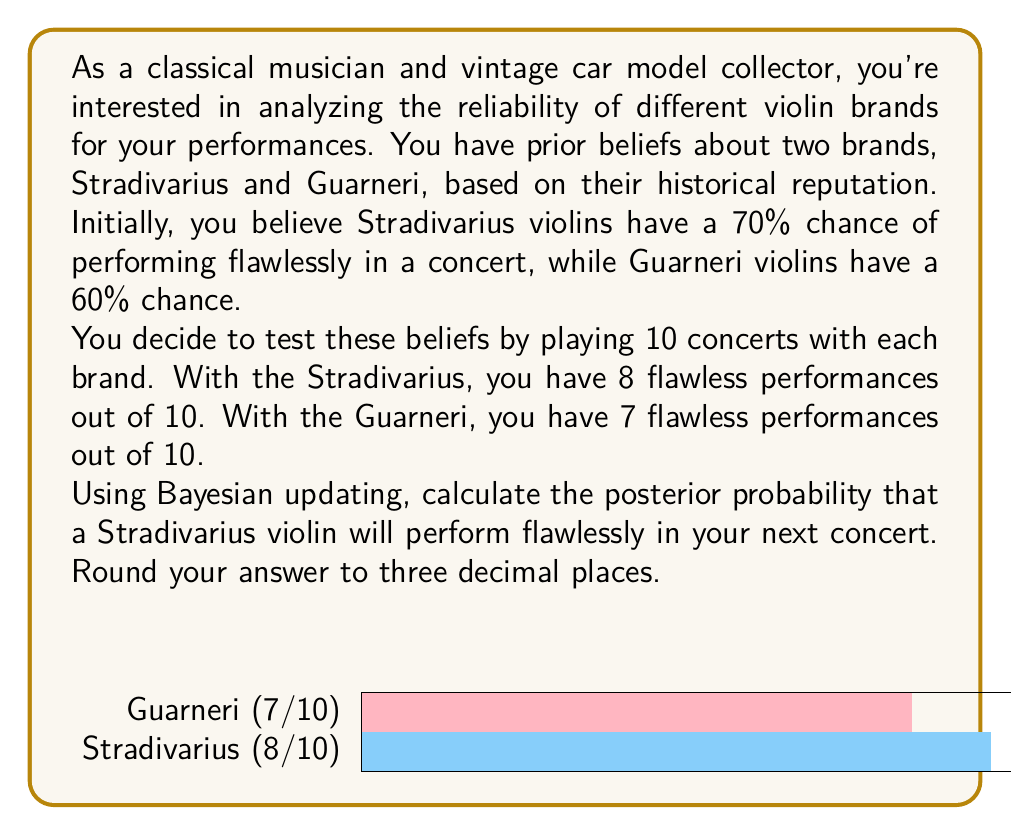Can you answer this question? Let's approach this step-by-step using Bayes' theorem:

1) Let $H$ be the event that a Stradivarius violin performs flawlessly.

2) Our prior probability: $P(H) = 0.70$

3) We observed 8 flawless performances out of 10 trials. This is our likelihood:
   $P(D|H) = \binom{10}{8} * 0.70^8 * 0.30^2 = 0.2334$

4) To calculate $P(D)$, we need to consider both possibilities (flawless and not flawless):
   $P(D) = P(D|H)P(H) + P(D|\neg H)P(\neg H)$
   $= (0.2334 * 0.70) + (\binom{10}{8} * 0.30^8 * 0.70^2 * 0.30)$
   $= 0.1634 + 0.0001 = 0.1635$

5) Now we can apply Bayes' theorem:

   $$P(H|D) = \frac{P(D|H)P(H)}{P(D)}$$

   $$P(H|D) = \frac{0.2334 * 0.70}{0.1635} = 0.9993$$

6) Rounding to three decimal places: 0.999

This means that after observing the new data, we are 99.9% confident that a Stradivarius violin will perform flawlessly in the next concert.
Answer: 0.999 